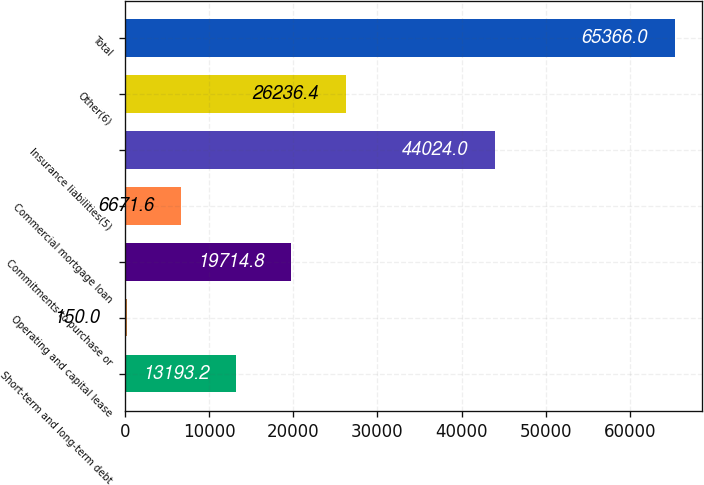Convert chart. <chart><loc_0><loc_0><loc_500><loc_500><bar_chart><fcel>Short-term and long-term debt<fcel>Operating and capital lease<fcel>Commitments to purchase or<fcel>Commercial mortgage loan<fcel>Insurance liabilities(5)<fcel>Other(6)<fcel>Total<nl><fcel>13193.2<fcel>150<fcel>19714.8<fcel>6671.6<fcel>44024<fcel>26236.4<fcel>65366<nl></chart> 